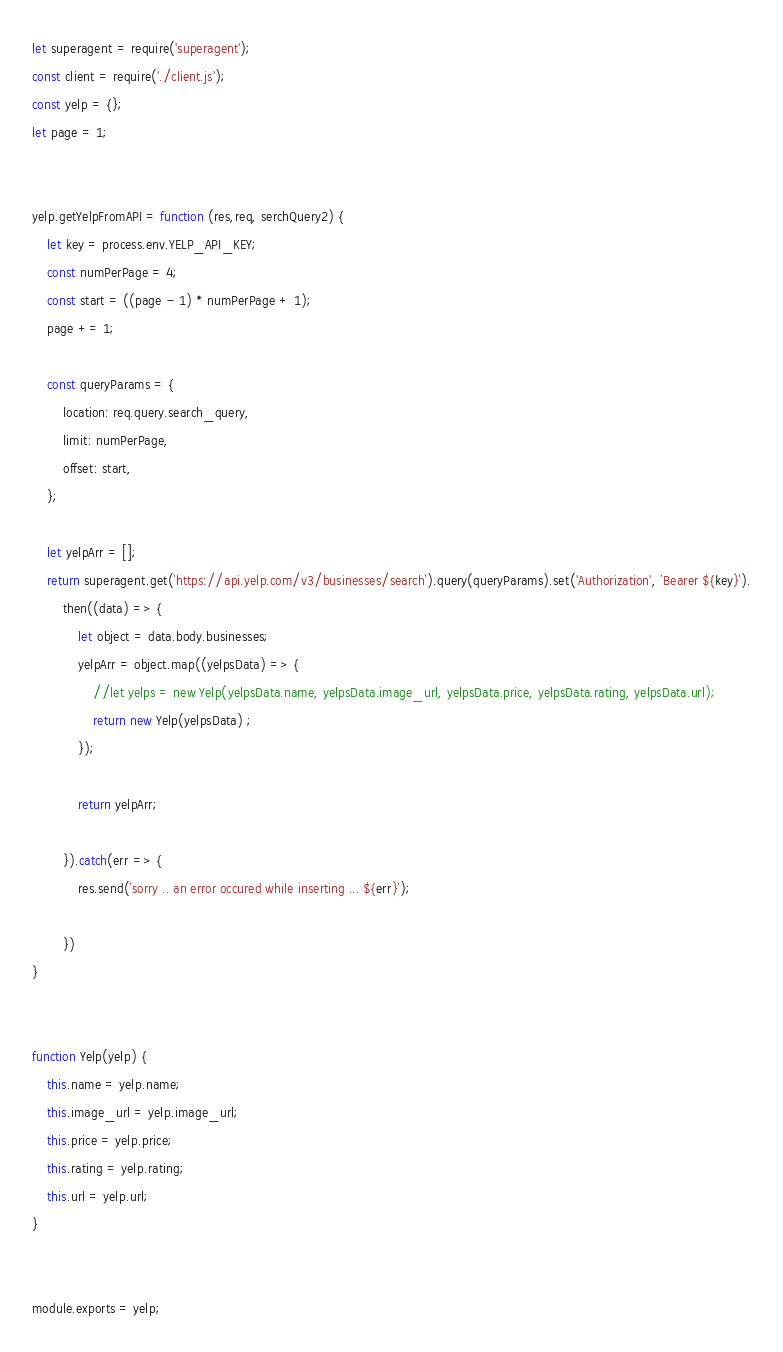Convert code to text. <code><loc_0><loc_0><loc_500><loc_500><_JavaScript_>


let superagent = require('superagent');
const client = require('./client.js');
const yelp = {};
let page = 1;


yelp.getYelpFromAPI = function (res,req, serchQuery2) {
    let key = process.env.YELP_API_KEY;
    const numPerPage = 4;
    const start = ((page - 1) * numPerPage + 1);
    page += 1;

    const queryParams = {
        location: req.query.search_query,
        limit: numPerPage,
        offset: start,
    };

    let yelpArr = [];
    return superagent.get(`https://api.yelp.com/v3/businesses/search`).query(queryParams).set('Authorization', `Bearer ${key}`).
        then((data) => {
            let object = data.body.businesses;
            yelpArr = object.map((yelpsData) => {
                //let yelps = new Yelp(yelpsData.name, yelpsData.image_url, yelpsData.price, yelpsData.rating, yelpsData.url);
                return new Yelp(yelpsData) ;
            });

            return yelpArr;

        }).catch(err => {
            res.send(`sorry .. an error occured while inserting ... ${err}`);

        })
}


function Yelp(yelp) {
    this.name = yelp.name;
    this.image_url = yelp.image_url;
    this.price = yelp.price;
    this.rating = yelp.rating;
    this.url = yelp.url;
}


module.exports = yelp;</code> 